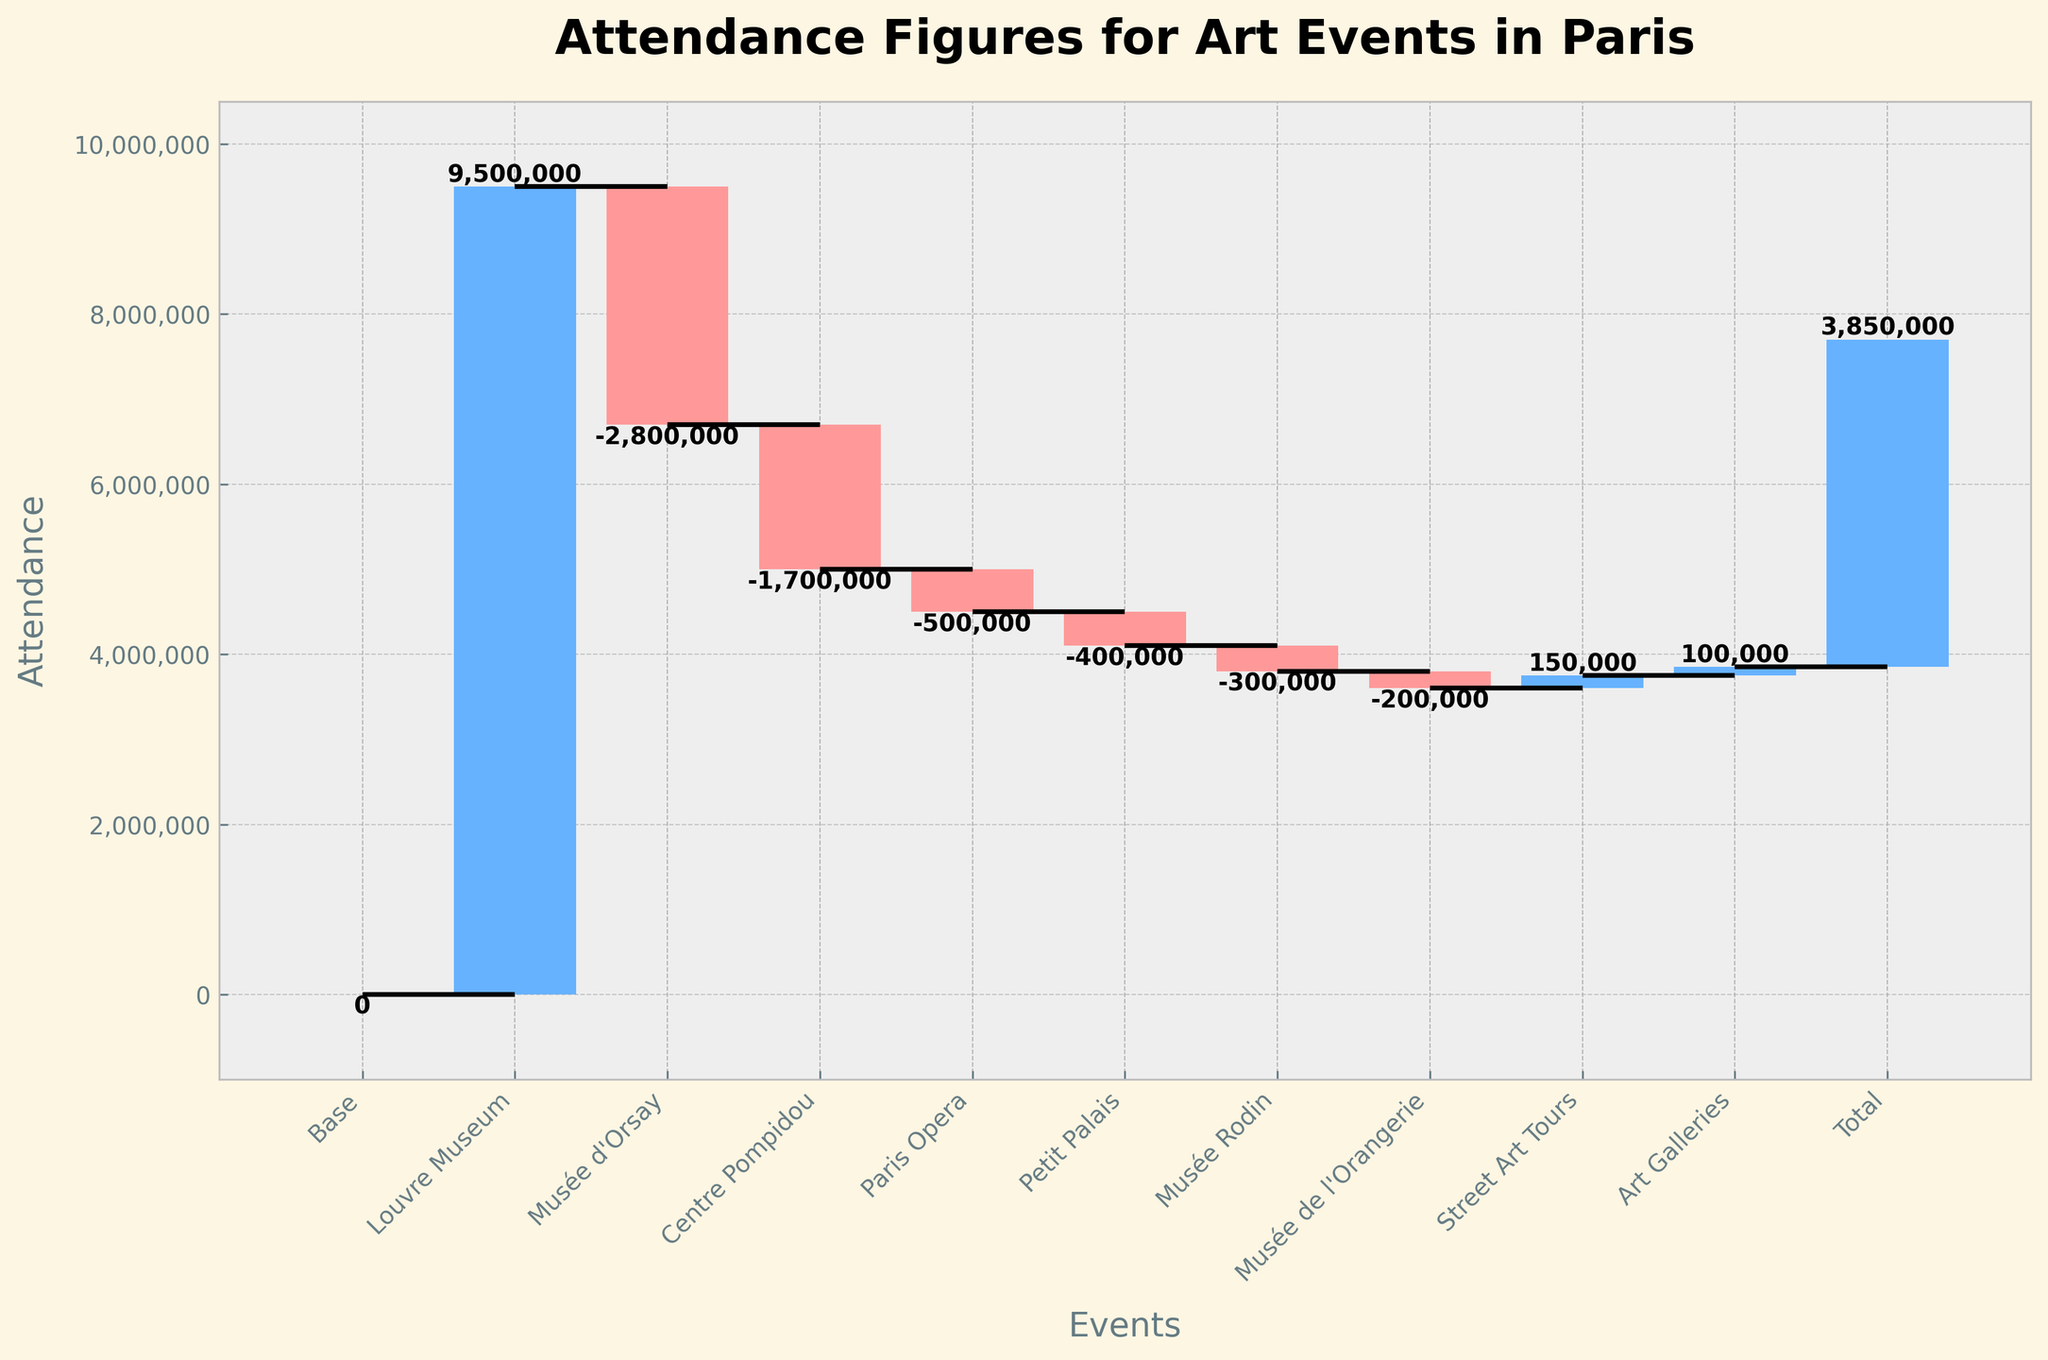What's the title of the chart? The title is typically at the top of the chart, centrally aligned, and usually larger in font size. Here, it states "Attendance Figures for Art Events in Paris."
Answer: Attendance Figures for Art Events in Paris What is the attendance figure for the Louvre Museum? By examining the specific bar labeled "Louvre Museum," we can see the attendance figure next to it. The figure indicated is 9,500,000.
Answer: 9,500,000 What is the drop in attendance from the Louvre Museum to the Musée d'Orsay? Subtract the attendance figure of the Musée d'Orsay (-2,800,000) from that of the Louvre Museum (9,500,000). The difference is 9,500,000 - 2,800,000 = 6,700,000.
Answer: 6,700,000 How many events have a negative attendance figure? Count all the bars with negative values. From the chart: Musée d'Orsay, Centre Pompidou, Paris Opera, Petit Palais, Musée Rodin, and Musée de l'Orangerie, resulting in a total of 6 events.
Answer: 6 Which event has the least attendance figure? Locate the smallest value in the chart bars. The Musée de l'Orangerie has the least attendance at -200,000.
Answer: Musée de l'Orangerie What is the net attendance after including Street Art Tours and Art Galleries? Sum up the individual attendances: Street Art Tours (150,000) and Art Galleries (100,000). The total net attendance is 150,000 + 100,000 = 250,000.
Answer: 250,000 What's the total attendance figure at the end? Refer to the bar labeled "Total" at the end of the chart which gives the cumulative final value, which is 3,850,000.
Answer: 3,850,000 How does the attendance at the Centre Pompidou compare to the Musée Rodin? The attendance at Centre Pompidou is -1,700,000, whereas for Musée Rodin it's -300,000. Since -1,700,000 < -300,000, the Centre Pompidou has a larger decrease in attendance.
Answer: The Centre Pompidou has a larger decrease in attendance What is the average drop in attendance among the negatively valued events? Calculate the average by summing the negative values and dividing by the number of such events: (-2,800,000 + -1,700,000 + -500,000 + -400,000 + -300,000 + -200,000) / 6 = -5,900,000 / 6 = -983,333.33.
Answer: -983,333.33 